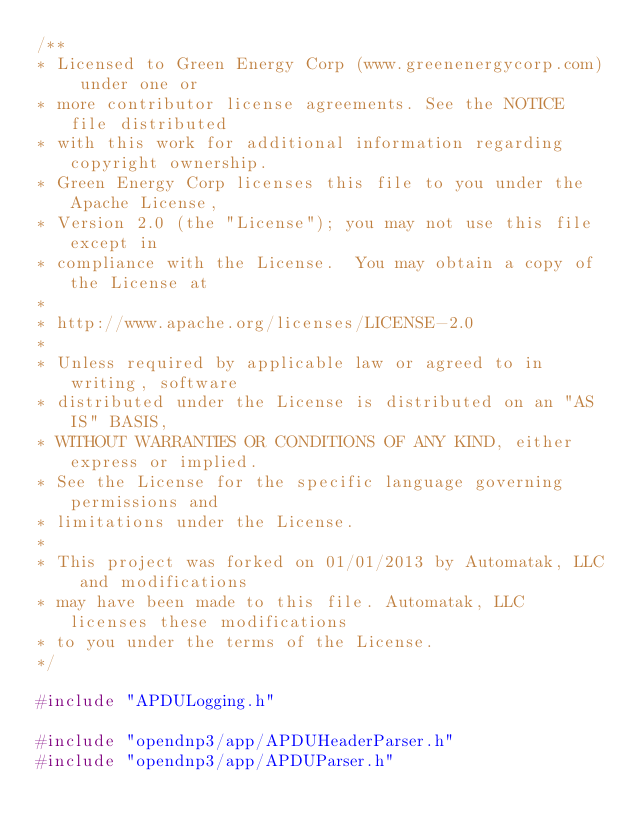<code> <loc_0><loc_0><loc_500><loc_500><_C++_>/**
* Licensed to Green Energy Corp (www.greenenergycorp.com) under one or
* more contributor license agreements. See the NOTICE file distributed
* with this work for additional information regarding copyright ownership.
* Green Energy Corp licenses this file to you under the Apache License,
* Version 2.0 (the "License"); you may not use this file except in
* compliance with the License.  You may obtain a copy of the License at
*
* http://www.apache.org/licenses/LICENSE-2.0
*
* Unless required by applicable law or agreed to in writing, software
* distributed under the License is distributed on an "AS IS" BASIS,
* WITHOUT WARRANTIES OR CONDITIONS OF ANY KIND, either express or implied.
* See the License for the specific language governing permissions and
* limitations under the License.
*
* This project was forked on 01/01/2013 by Automatak, LLC and modifications
* may have been made to this file. Automatak, LLC licenses these modifications
* to you under the terms of the License.
*/

#include "APDULogging.h"

#include "opendnp3/app/APDUHeaderParser.h"
#include "opendnp3/app/APDUParser.h"
</code> 